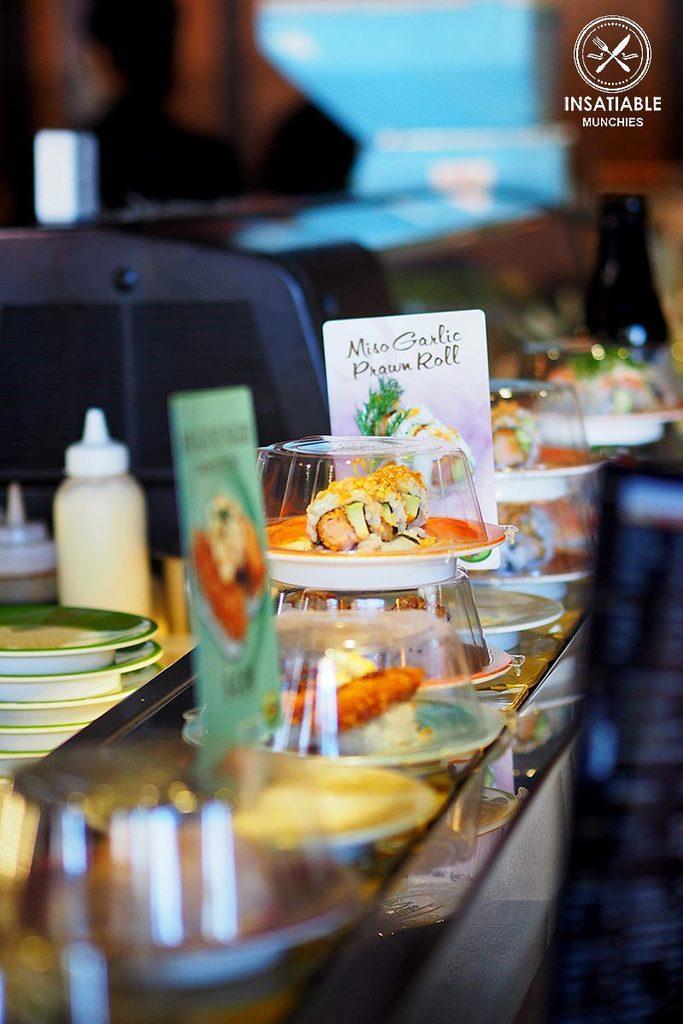In one or two sentences, can you explain what this image depicts? Here we can see few plates behind it there is a bottle. And these are all some bowls in which inside there is food item. 